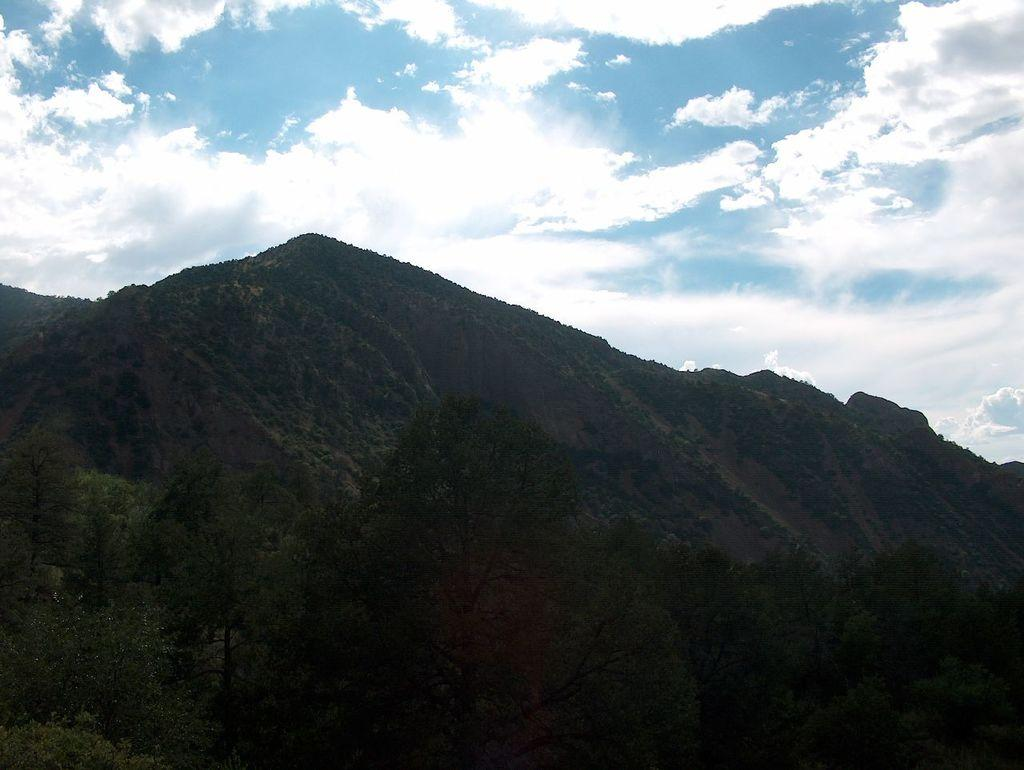What type of vegetation is present at the bottom of the image? There are trees at the bottom of the image. What geographical feature is located in the middle of the image? There is a hill in the middle of the image. What is the condition of the sky in the image? The sky is cloudy at the top of the image. What type of plate is used to serve the trees in the image? There is no plate present in the image, as the trees are not being served. What scientific theory can be observed in the image? There is no specific scientific theory observable in the image; it simply depicts trees, a hill, and a cloudy sky. 